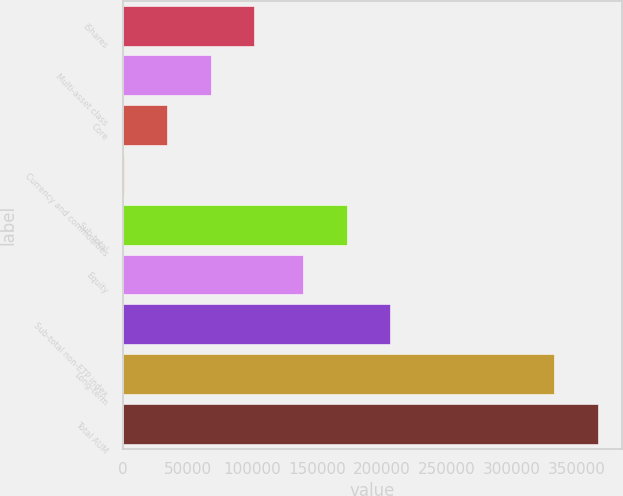Convert chart to OTSL. <chart><loc_0><loc_0><loc_500><loc_500><bar_chart><fcel>iShares<fcel>Multi-asset class<fcel>Core<fcel>Currency and commodities<fcel>Sub-total<fcel>Equity<fcel>Sub-total non-ETP index<fcel>Long-term<fcel>Total AUM<nl><fcel>101706<fcel>68075.6<fcel>34444.8<fcel>814<fcel>172721<fcel>139090<fcel>206352<fcel>333143<fcel>366774<nl></chart> 